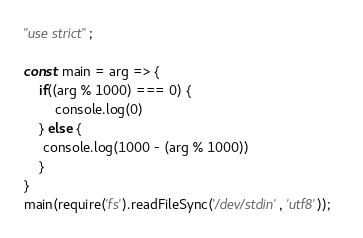Convert code to text. <code><loc_0><loc_0><loc_500><loc_500><_JavaScript_>"use strict";

const main = arg => {
    if((arg % 1000) === 0) {
        console.log(0)
    } else {
     console.log(1000 - (arg % 1000))   
    }
}
main(require('fs').readFileSync('/dev/stdin', 'utf8'));  </code> 